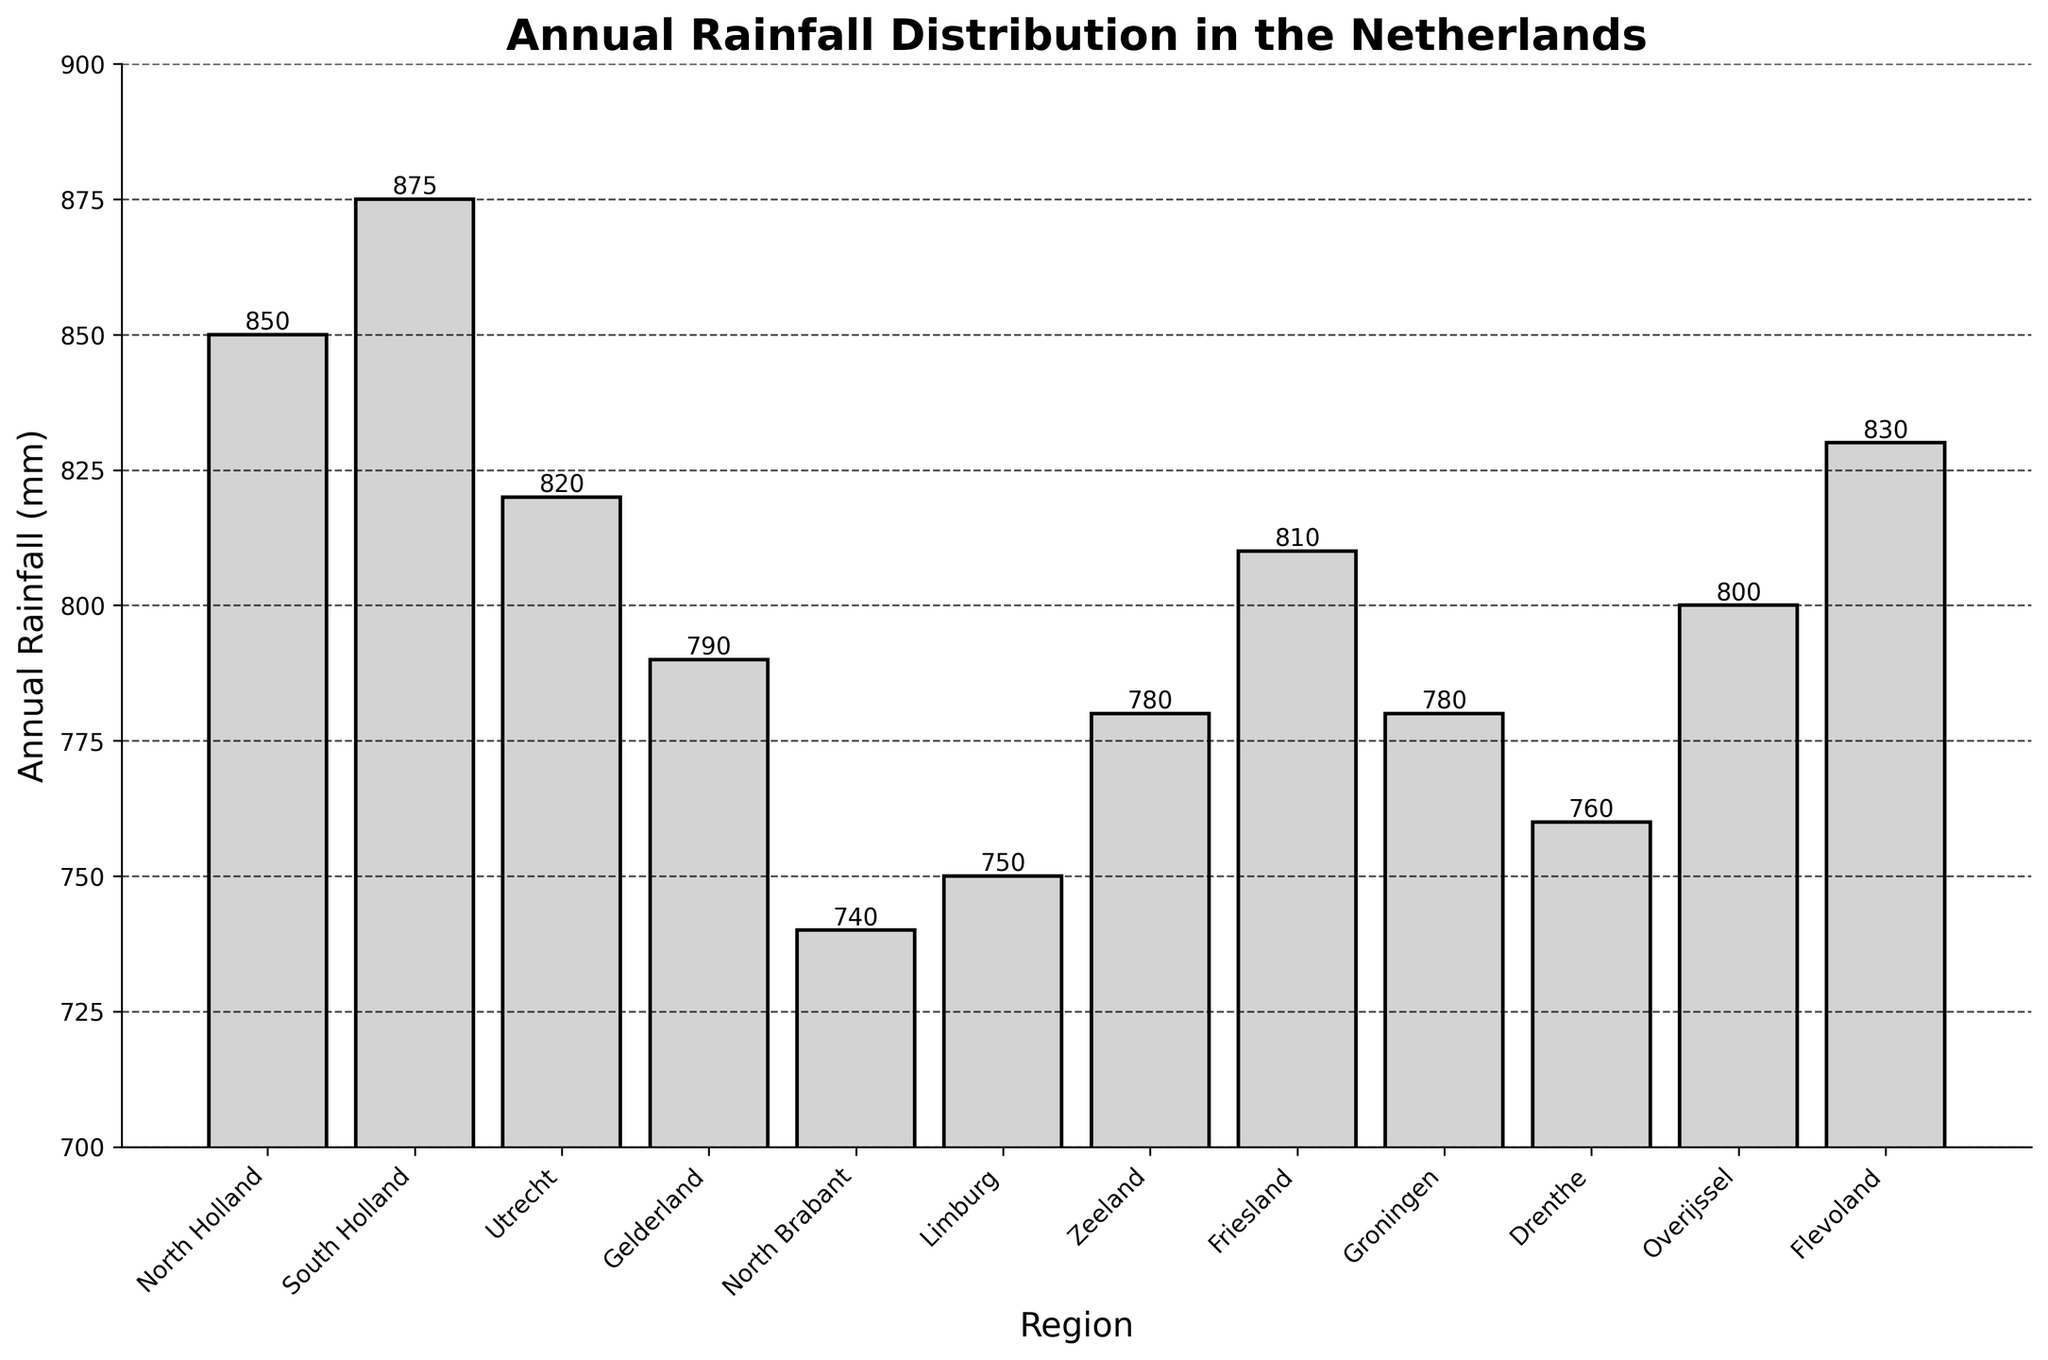Which region receives the highest annual rainfall? The tallest bar represents the region with the highest annual rainfall. Identify the region corresponding to the tallest bar.
Answer: South Holland Which two regions have the smallest difference in annual rainfall? Compare the heights of the bars and find the two regions whose bars have the smallest difference in height.
Answer: Groningen and Zeeland What is the total annual rainfall for the regions of North Holland and South Holland combined? Sum the annual rainfall values for North Holland and South Holland: 850 mm + 875 mm.
Answer: 1725 mm Which region has the least annual rainfall? The shortest bar represents the region with the least annual rainfall. Identify the region corresponding to the shortest bar.
Answer: North Brabant How much more annual rainfall does Utrecht receive compared to Drenthe? Subtract the annual rainfall value of Drenthe from that of Utrecht: 820 mm - 760 mm.
Answer: 60 mm How does the annual rainfall in Flevoland compare to the average annual rainfall of Drenthe and Overijssel? Calculate the average annual rainfall of Drenthe and Overijssel [(760 mm + 800 mm)/2], then compare it to the annual rainfall of Flevoland: 830 mm vs (760+800)/2.
Answer: Flevoland has 30 mm more Which regions receive more than 800 mm of annual rainfall? Identify all regions whose bars are taller than the 800 mm mark on the y-axis.
Answer: North Holland, South Holland, Utrecht, Friesland, Flevoland Rank the top three regions in terms of annual rainfall. Compare the heights of all bars and list the top three tallest.
Answer: South Holland, North Holland, Flevoland What is the average annual rainfall across all regions? Sum the annual rainfall values, then divide by the total number of regions: (850 + 875 + 820 + 790 + 740 + 750 + 780 + 810 + 780 + 760 + 800 + 830) / 12.
Answer: 793 mm 